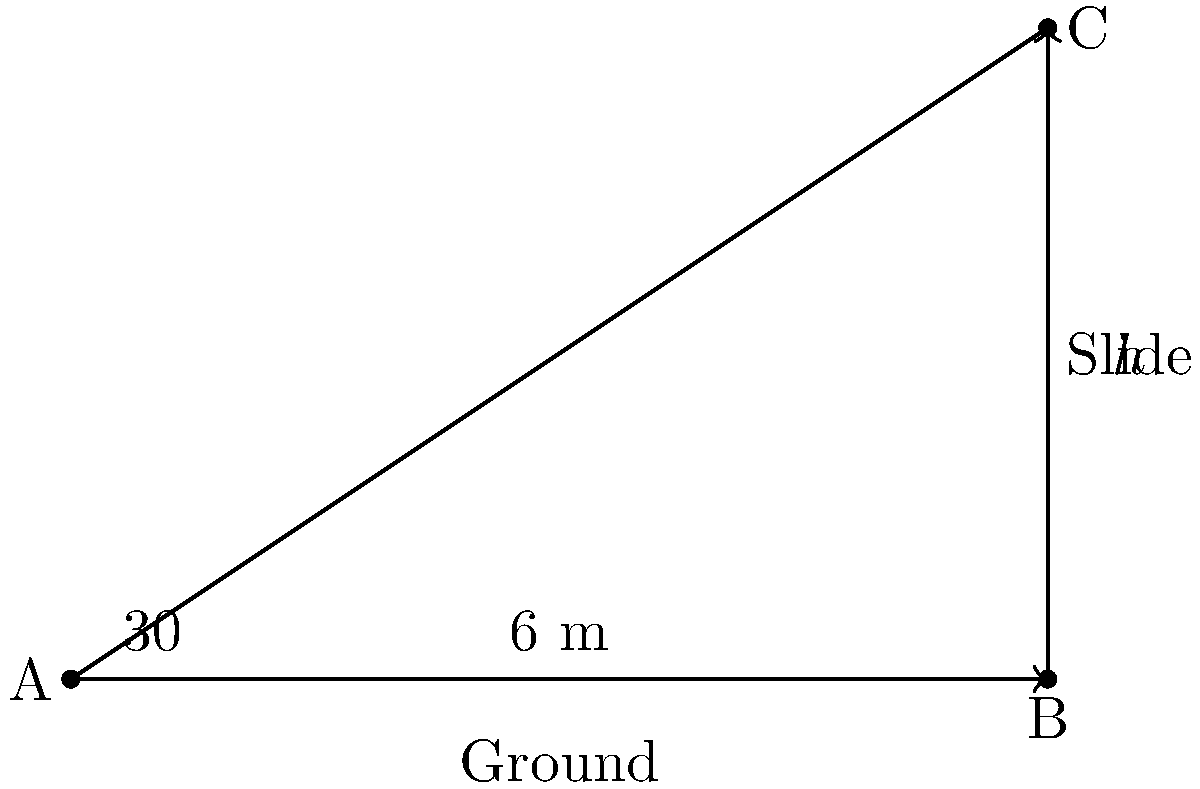At a charity event, we're installing a new playground slide. The angle of elevation from the ground to the top of the slide is 30°, and the distance from the base of the slide to where we're standing is 6 meters. What is the height of the slide to the nearest tenth of a meter? To solve this problem, we'll use the tangent function from trigonometry. Let's approach this step-by-step:

1) In a right triangle, tangent of an angle is the ratio of the opposite side to the adjacent side.

2) In this case:
   - The angle is 30°
   - The adjacent side (ground distance) is 6 meters
   - The opposite side is the height we're looking for (let's call it $h$)

3) We can write the equation:
   $\tan(30°) = \frac{h}{6}$

4) Rearranging the equation to solve for $h$:
   $h = 6 \tan(30°)$

5) Now, let's calculate:
   $\tan(30°) \approx 0.5773502692$

6) Multiplying by 6:
   $h = 6 * 0.5773502692 \approx 3.464101615$

7) Rounding to the nearest tenth:
   $h \approx 3.5$ meters

Therefore, the height of the slide is approximately 3.5 meters.
Answer: 3.5 m 